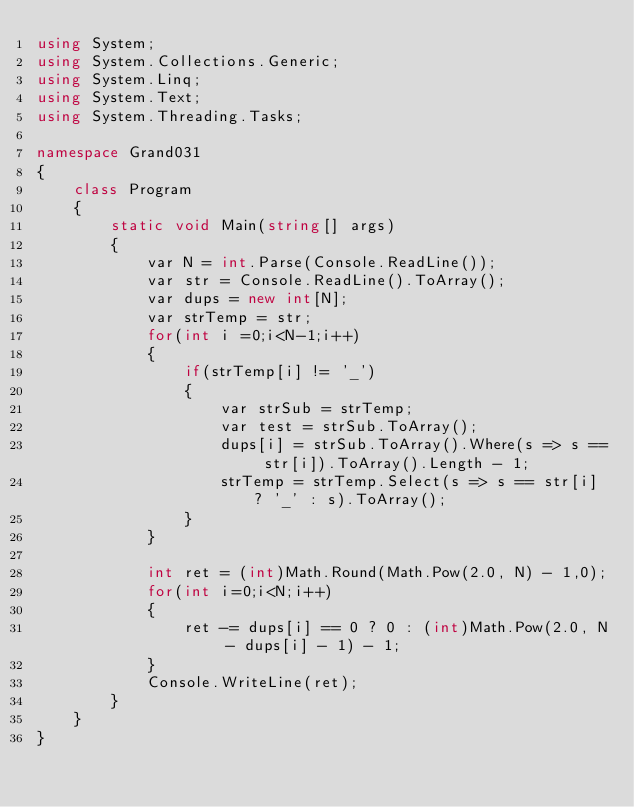<code> <loc_0><loc_0><loc_500><loc_500><_C#_>using System;
using System.Collections.Generic;
using System.Linq;
using System.Text;
using System.Threading.Tasks;

namespace Grand031
{
    class Program
    {
        static void Main(string[] args)
        {
            var N = int.Parse(Console.ReadLine());
            var str = Console.ReadLine().ToArray();
            var dups = new int[N];
            var strTemp = str;
            for(int i =0;i<N-1;i++)
            {
                if(strTemp[i] != '_')
                {
                    var strSub = strTemp;
                    var test = strSub.ToArray(); 
                    dups[i] = strSub.ToArray().Where(s => s == str[i]).ToArray().Length - 1;
                    strTemp = strTemp.Select(s => s == str[i] ? '_' : s).ToArray();
                }
            }
            
            int ret = (int)Math.Round(Math.Pow(2.0, N) - 1,0);
            for(int i=0;i<N;i++)
            {
                ret -= dups[i] == 0 ? 0 : (int)Math.Pow(2.0, N - dups[i] - 1) - 1;
            }
            Console.WriteLine(ret);
        }
    }
}
</code> 